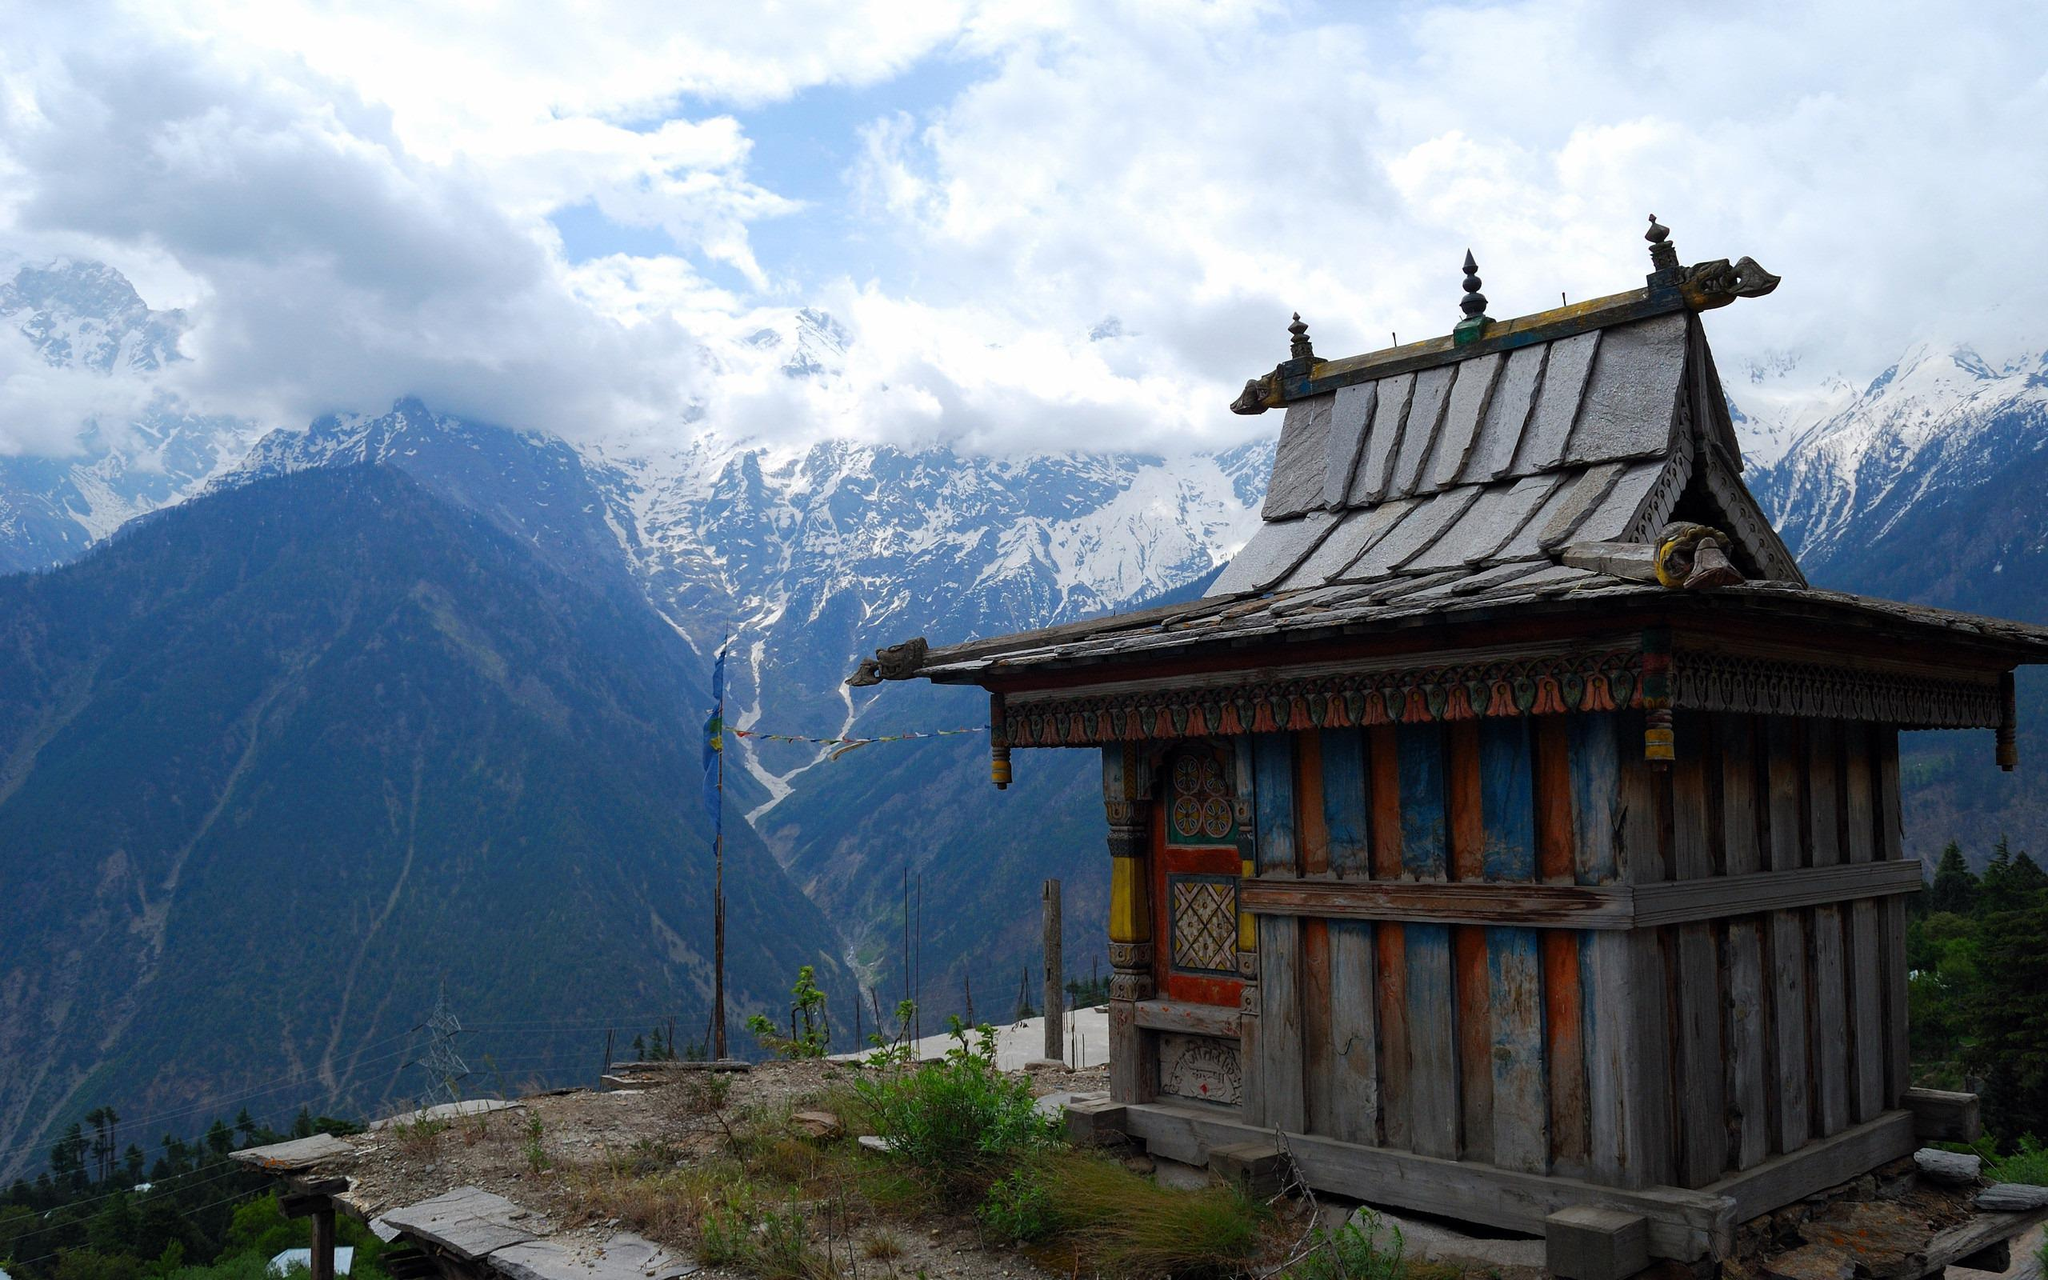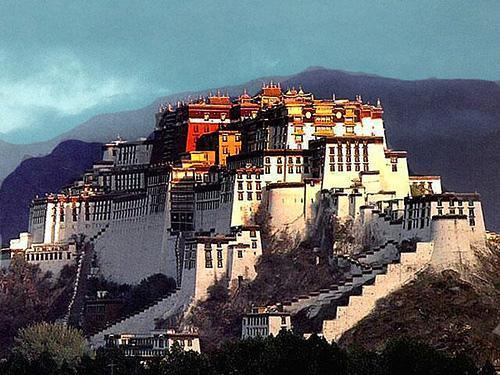The first image is the image on the left, the second image is the image on the right. Considering the images on both sides, is "In one image, the walls running up the mountain towards a monastery are built up the steep slopes in a stair-like design." valid? Answer yes or no. Yes. The first image is the image on the left, the second image is the image on the right. Evaluate the accuracy of this statement regarding the images: "A jagged, staircase-like wall goes up a hillside with a monastery on top, in one image.". Is it true? Answer yes or no. Yes. 